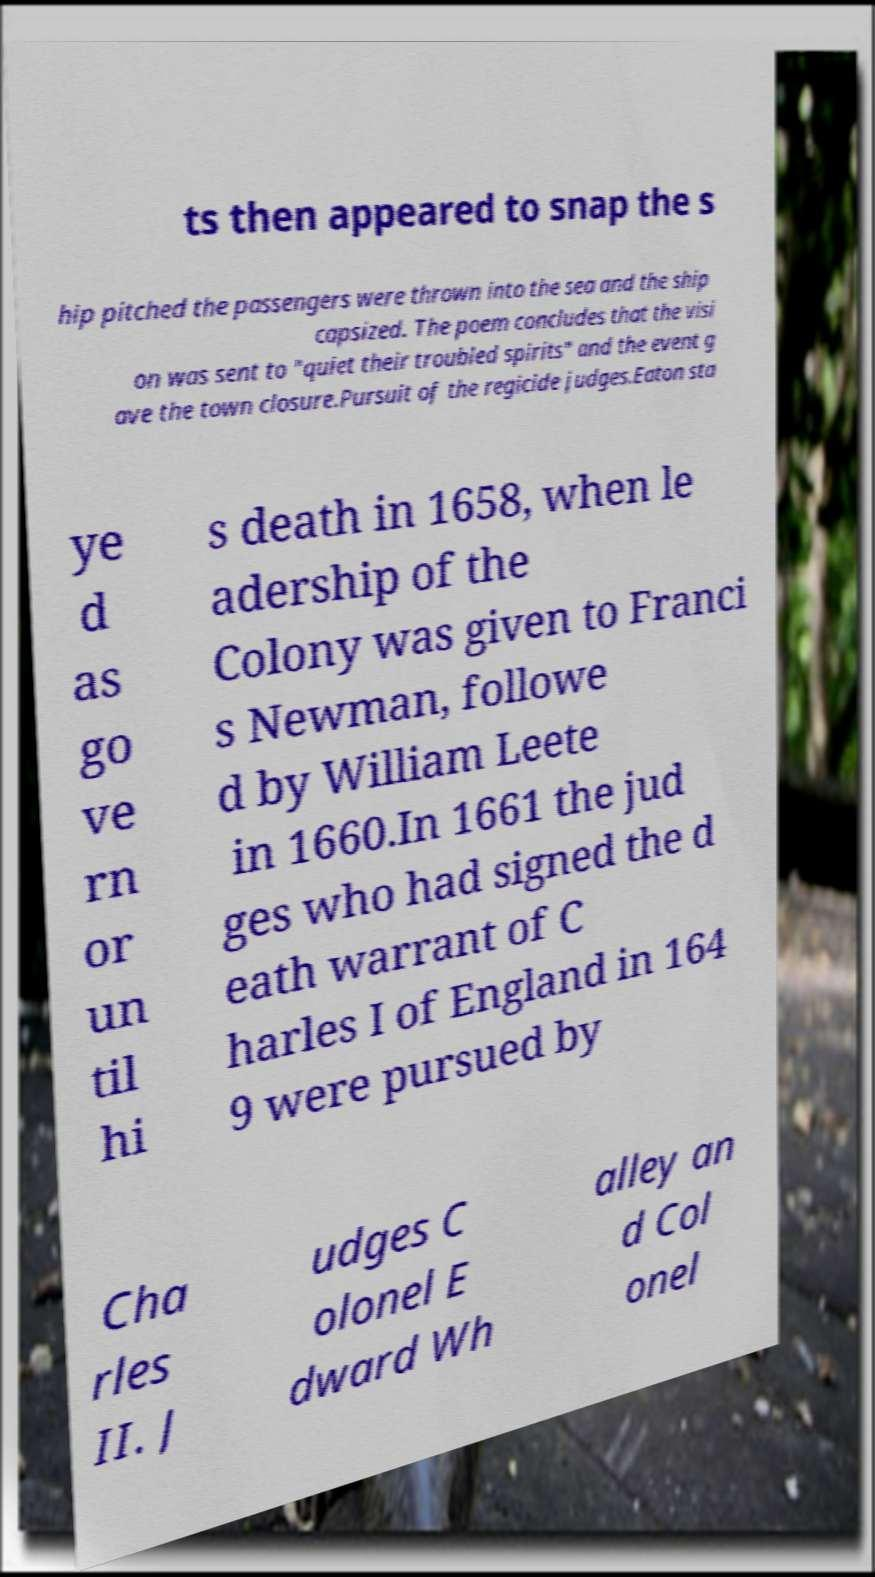I need the written content from this picture converted into text. Can you do that? ts then appeared to snap the s hip pitched the passengers were thrown into the sea and the ship capsized. The poem concludes that the visi on was sent to "quiet their troubled spirits" and the event g ave the town closure.Pursuit of the regicide judges.Eaton sta ye d as go ve rn or un til hi s death in 1658, when le adership of the Colony was given to Franci s Newman, followe d by William Leete in 1660.In 1661 the jud ges who had signed the d eath warrant of C harles I of England in 164 9 were pursued by Cha rles II. J udges C olonel E dward Wh alley an d Col onel 